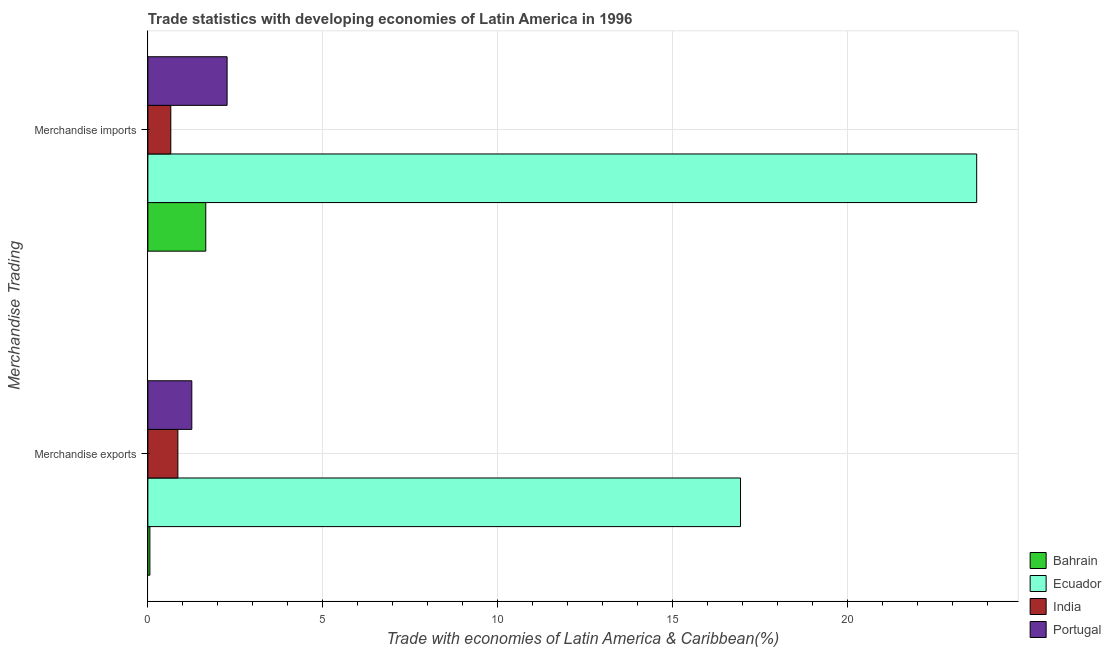How many bars are there on the 1st tick from the bottom?
Provide a succinct answer. 4. What is the label of the 1st group of bars from the top?
Offer a very short reply. Merchandise imports. What is the merchandise imports in Bahrain?
Offer a terse response. 1.66. Across all countries, what is the maximum merchandise imports?
Provide a short and direct response. 23.7. Across all countries, what is the minimum merchandise exports?
Your response must be concise. 0.06. In which country was the merchandise exports maximum?
Your answer should be compact. Ecuador. In which country was the merchandise imports minimum?
Offer a terse response. India. What is the total merchandise imports in the graph?
Your response must be concise. 28.27. What is the difference between the merchandise exports in Portugal and that in Ecuador?
Make the answer very short. -15.69. What is the difference between the merchandise exports in India and the merchandise imports in Portugal?
Provide a succinct answer. -1.41. What is the average merchandise imports per country?
Offer a very short reply. 7.07. What is the difference between the merchandise exports and merchandise imports in India?
Ensure brevity in your answer.  0.2. In how many countries, is the merchandise imports greater than 8 %?
Provide a short and direct response. 1. What is the ratio of the merchandise exports in India to that in Portugal?
Your answer should be very brief. 0.68. Is the merchandise imports in Ecuador less than that in India?
Your answer should be very brief. No. What does the 2nd bar from the top in Merchandise exports represents?
Your answer should be compact. India. What does the 2nd bar from the bottom in Merchandise exports represents?
Your answer should be compact. Ecuador. How many bars are there?
Make the answer very short. 8. Are all the bars in the graph horizontal?
Keep it short and to the point. Yes. How many countries are there in the graph?
Your answer should be very brief. 4. What is the difference between two consecutive major ticks on the X-axis?
Provide a succinct answer. 5. Does the graph contain grids?
Keep it short and to the point. Yes. Where does the legend appear in the graph?
Keep it short and to the point. Bottom right. What is the title of the graph?
Provide a short and direct response. Trade statistics with developing economies of Latin America in 1996. Does "Upper middle income" appear as one of the legend labels in the graph?
Make the answer very short. No. What is the label or title of the X-axis?
Ensure brevity in your answer.  Trade with economies of Latin America & Caribbean(%). What is the label or title of the Y-axis?
Your answer should be very brief. Merchandise Trading. What is the Trade with economies of Latin America & Caribbean(%) of Bahrain in Merchandise exports?
Provide a short and direct response. 0.06. What is the Trade with economies of Latin America & Caribbean(%) of Ecuador in Merchandise exports?
Keep it short and to the point. 16.94. What is the Trade with economies of Latin America & Caribbean(%) in India in Merchandise exports?
Provide a succinct answer. 0.86. What is the Trade with economies of Latin America & Caribbean(%) of Portugal in Merchandise exports?
Your answer should be compact. 1.26. What is the Trade with economies of Latin America & Caribbean(%) in Bahrain in Merchandise imports?
Offer a terse response. 1.66. What is the Trade with economies of Latin America & Caribbean(%) of Ecuador in Merchandise imports?
Ensure brevity in your answer.  23.7. What is the Trade with economies of Latin America & Caribbean(%) in India in Merchandise imports?
Provide a succinct answer. 0.66. What is the Trade with economies of Latin America & Caribbean(%) in Portugal in Merchandise imports?
Provide a short and direct response. 2.27. Across all Merchandise Trading, what is the maximum Trade with economies of Latin America & Caribbean(%) of Bahrain?
Offer a terse response. 1.66. Across all Merchandise Trading, what is the maximum Trade with economies of Latin America & Caribbean(%) of Ecuador?
Offer a terse response. 23.7. Across all Merchandise Trading, what is the maximum Trade with economies of Latin America & Caribbean(%) of India?
Give a very brief answer. 0.86. Across all Merchandise Trading, what is the maximum Trade with economies of Latin America & Caribbean(%) in Portugal?
Ensure brevity in your answer.  2.27. Across all Merchandise Trading, what is the minimum Trade with economies of Latin America & Caribbean(%) of Bahrain?
Your answer should be compact. 0.06. Across all Merchandise Trading, what is the minimum Trade with economies of Latin America & Caribbean(%) of Ecuador?
Keep it short and to the point. 16.94. Across all Merchandise Trading, what is the minimum Trade with economies of Latin America & Caribbean(%) of India?
Give a very brief answer. 0.66. Across all Merchandise Trading, what is the minimum Trade with economies of Latin America & Caribbean(%) in Portugal?
Provide a succinct answer. 1.26. What is the total Trade with economies of Latin America & Caribbean(%) in Bahrain in the graph?
Make the answer very short. 1.71. What is the total Trade with economies of Latin America & Caribbean(%) of Ecuador in the graph?
Provide a short and direct response. 40.64. What is the total Trade with economies of Latin America & Caribbean(%) in India in the graph?
Provide a succinct answer. 1.51. What is the total Trade with economies of Latin America & Caribbean(%) in Portugal in the graph?
Give a very brief answer. 3.52. What is the difference between the Trade with economies of Latin America & Caribbean(%) of Bahrain in Merchandise exports and that in Merchandise imports?
Keep it short and to the point. -1.6. What is the difference between the Trade with economies of Latin America & Caribbean(%) of Ecuador in Merchandise exports and that in Merchandise imports?
Your answer should be very brief. -6.75. What is the difference between the Trade with economies of Latin America & Caribbean(%) of India in Merchandise exports and that in Merchandise imports?
Keep it short and to the point. 0.2. What is the difference between the Trade with economies of Latin America & Caribbean(%) of Portugal in Merchandise exports and that in Merchandise imports?
Your answer should be compact. -1.01. What is the difference between the Trade with economies of Latin America & Caribbean(%) in Bahrain in Merchandise exports and the Trade with economies of Latin America & Caribbean(%) in Ecuador in Merchandise imports?
Provide a succinct answer. -23.64. What is the difference between the Trade with economies of Latin America & Caribbean(%) in Bahrain in Merchandise exports and the Trade with economies of Latin America & Caribbean(%) in India in Merchandise imports?
Offer a terse response. -0.6. What is the difference between the Trade with economies of Latin America & Caribbean(%) of Bahrain in Merchandise exports and the Trade with economies of Latin America & Caribbean(%) of Portugal in Merchandise imports?
Your answer should be very brief. -2.21. What is the difference between the Trade with economies of Latin America & Caribbean(%) of Ecuador in Merchandise exports and the Trade with economies of Latin America & Caribbean(%) of India in Merchandise imports?
Provide a succinct answer. 16.29. What is the difference between the Trade with economies of Latin America & Caribbean(%) of Ecuador in Merchandise exports and the Trade with economies of Latin America & Caribbean(%) of Portugal in Merchandise imports?
Give a very brief answer. 14.68. What is the difference between the Trade with economies of Latin America & Caribbean(%) in India in Merchandise exports and the Trade with economies of Latin America & Caribbean(%) in Portugal in Merchandise imports?
Your answer should be very brief. -1.41. What is the average Trade with economies of Latin America & Caribbean(%) in Bahrain per Merchandise Trading?
Your answer should be compact. 0.86. What is the average Trade with economies of Latin America & Caribbean(%) in Ecuador per Merchandise Trading?
Give a very brief answer. 20.32. What is the average Trade with economies of Latin America & Caribbean(%) of India per Merchandise Trading?
Your answer should be very brief. 0.76. What is the average Trade with economies of Latin America & Caribbean(%) of Portugal per Merchandise Trading?
Offer a terse response. 1.76. What is the difference between the Trade with economies of Latin America & Caribbean(%) in Bahrain and Trade with economies of Latin America & Caribbean(%) in Ecuador in Merchandise exports?
Ensure brevity in your answer.  -16.89. What is the difference between the Trade with economies of Latin America & Caribbean(%) in Bahrain and Trade with economies of Latin America & Caribbean(%) in India in Merchandise exports?
Keep it short and to the point. -0.8. What is the difference between the Trade with economies of Latin America & Caribbean(%) of Bahrain and Trade with economies of Latin America & Caribbean(%) of Portugal in Merchandise exports?
Provide a short and direct response. -1.2. What is the difference between the Trade with economies of Latin America & Caribbean(%) of Ecuador and Trade with economies of Latin America & Caribbean(%) of India in Merchandise exports?
Ensure brevity in your answer.  16.09. What is the difference between the Trade with economies of Latin America & Caribbean(%) of Ecuador and Trade with economies of Latin America & Caribbean(%) of Portugal in Merchandise exports?
Provide a short and direct response. 15.69. What is the difference between the Trade with economies of Latin America & Caribbean(%) in India and Trade with economies of Latin America & Caribbean(%) in Portugal in Merchandise exports?
Provide a short and direct response. -0.4. What is the difference between the Trade with economies of Latin America & Caribbean(%) of Bahrain and Trade with economies of Latin America & Caribbean(%) of Ecuador in Merchandise imports?
Give a very brief answer. -22.04. What is the difference between the Trade with economies of Latin America & Caribbean(%) in Bahrain and Trade with economies of Latin America & Caribbean(%) in India in Merchandise imports?
Give a very brief answer. 1. What is the difference between the Trade with economies of Latin America & Caribbean(%) in Bahrain and Trade with economies of Latin America & Caribbean(%) in Portugal in Merchandise imports?
Your answer should be compact. -0.61. What is the difference between the Trade with economies of Latin America & Caribbean(%) of Ecuador and Trade with economies of Latin America & Caribbean(%) of India in Merchandise imports?
Your answer should be very brief. 23.04. What is the difference between the Trade with economies of Latin America & Caribbean(%) of Ecuador and Trade with economies of Latin America & Caribbean(%) of Portugal in Merchandise imports?
Your answer should be very brief. 21.43. What is the difference between the Trade with economies of Latin America & Caribbean(%) in India and Trade with economies of Latin America & Caribbean(%) in Portugal in Merchandise imports?
Ensure brevity in your answer.  -1.61. What is the ratio of the Trade with economies of Latin America & Caribbean(%) of Bahrain in Merchandise exports to that in Merchandise imports?
Offer a terse response. 0.03. What is the ratio of the Trade with economies of Latin America & Caribbean(%) in Ecuador in Merchandise exports to that in Merchandise imports?
Your response must be concise. 0.71. What is the ratio of the Trade with economies of Latin America & Caribbean(%) of India in Merchandise exports to that in Merchandise imports?
Keep it short and to the point. 1.31. What is the ratio of the Trade with economies of Latin America & Caribbean(%) of Portugal in Merchandise exports to that in Merchandise imports?
Give a very brief answer. 0.55. What is the difference between the highest and the second highest Trade with economies of Latin America & Caribbean(%) of Bahrain?
Keep it short and to the point. 1.6. What is the difference between the highest and the second highest Trade with economies of Latin America & Caribbean(%) of Ecuador?
Offer a terse response. 6.75. What is the difference between the highest and the second highest Trade with economies of Latin America & Caribbean(%) in India?
Provide a short and direct response. 0.2. What is the difference between the highest and the second highest Trade with economies of Latin America & Caribbean(%) in Portugal?
Your answer should be compact. 1.01. What is the difference between the highest and the lowest Trade with economies of Latin America & Caribbean(%) of Bahrain?
Make the answer very short. 1.6. What is the difference between the highest and the lowest Trade with economies of Latin America & Caribbean(%) of Ecuador?
Keep it short and to the point. 6.75. What is the difference between the highest and the lowest Trade with economies of Latin America & Caribbean(%) in India?
Provide a succinct answer. 0.2. 